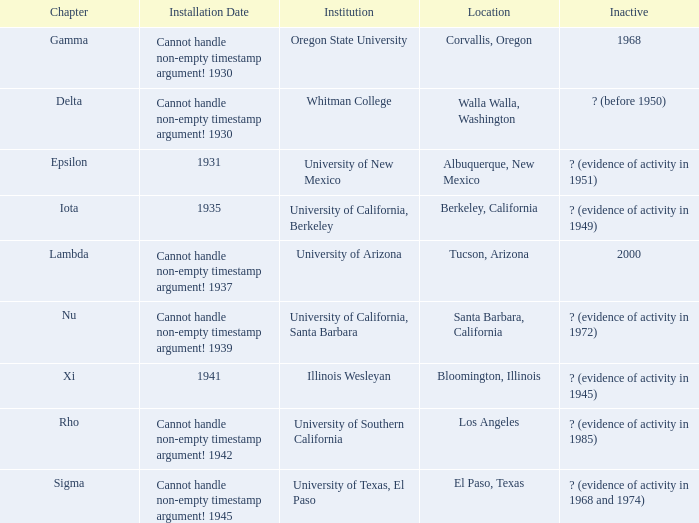When was the delta chapter installed? Cannot handle non-empty timestamp argument! 1930. 